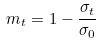Convert formula to latex. <formula><loc_0><loc_0><loc_500><loc_500>m _ { t } = 1 - \frac { \sigma _ { t } } { \sigma _ { 0 } }</formula> 